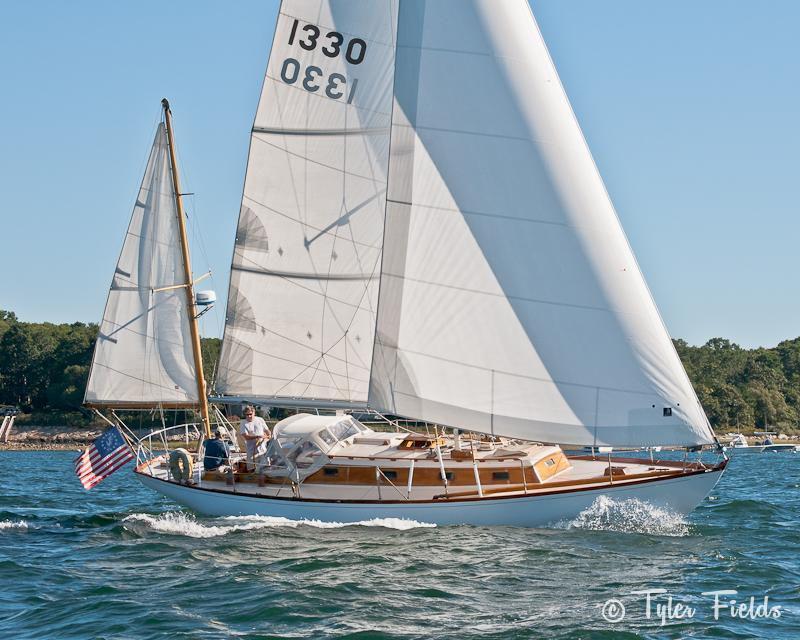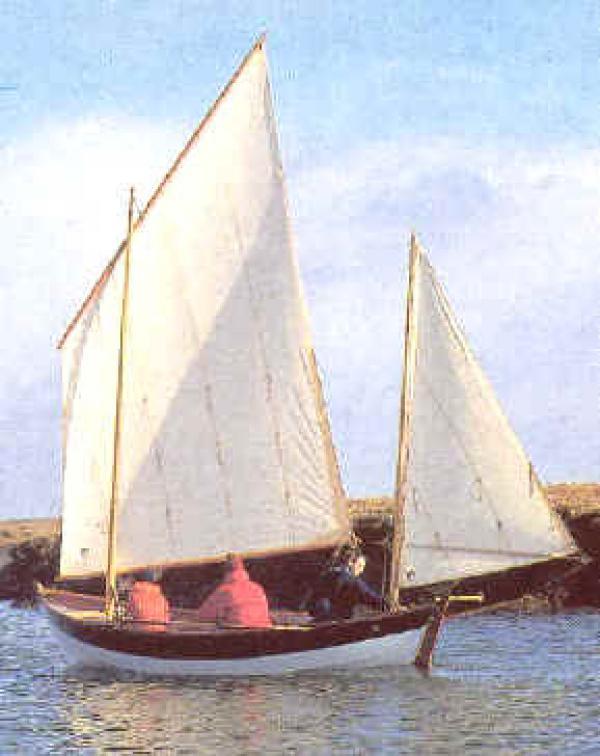The first image is the image on the left, the second image is the image on the right. For the images displayed, is the sentence "There appear to be fewer than four people on each boat." factually correct? Answer yes or no. Yes. 